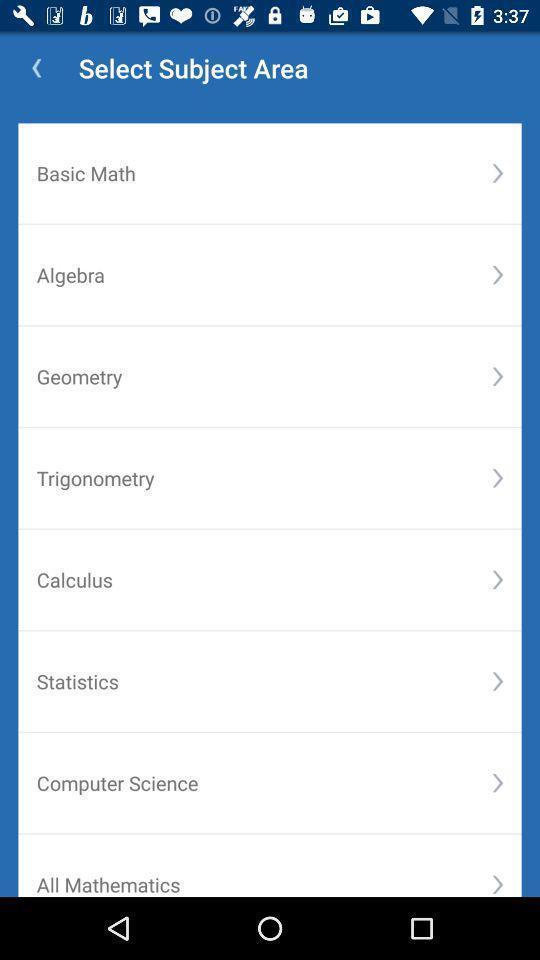Describe the content in this image. Page to select course in the learning app. 